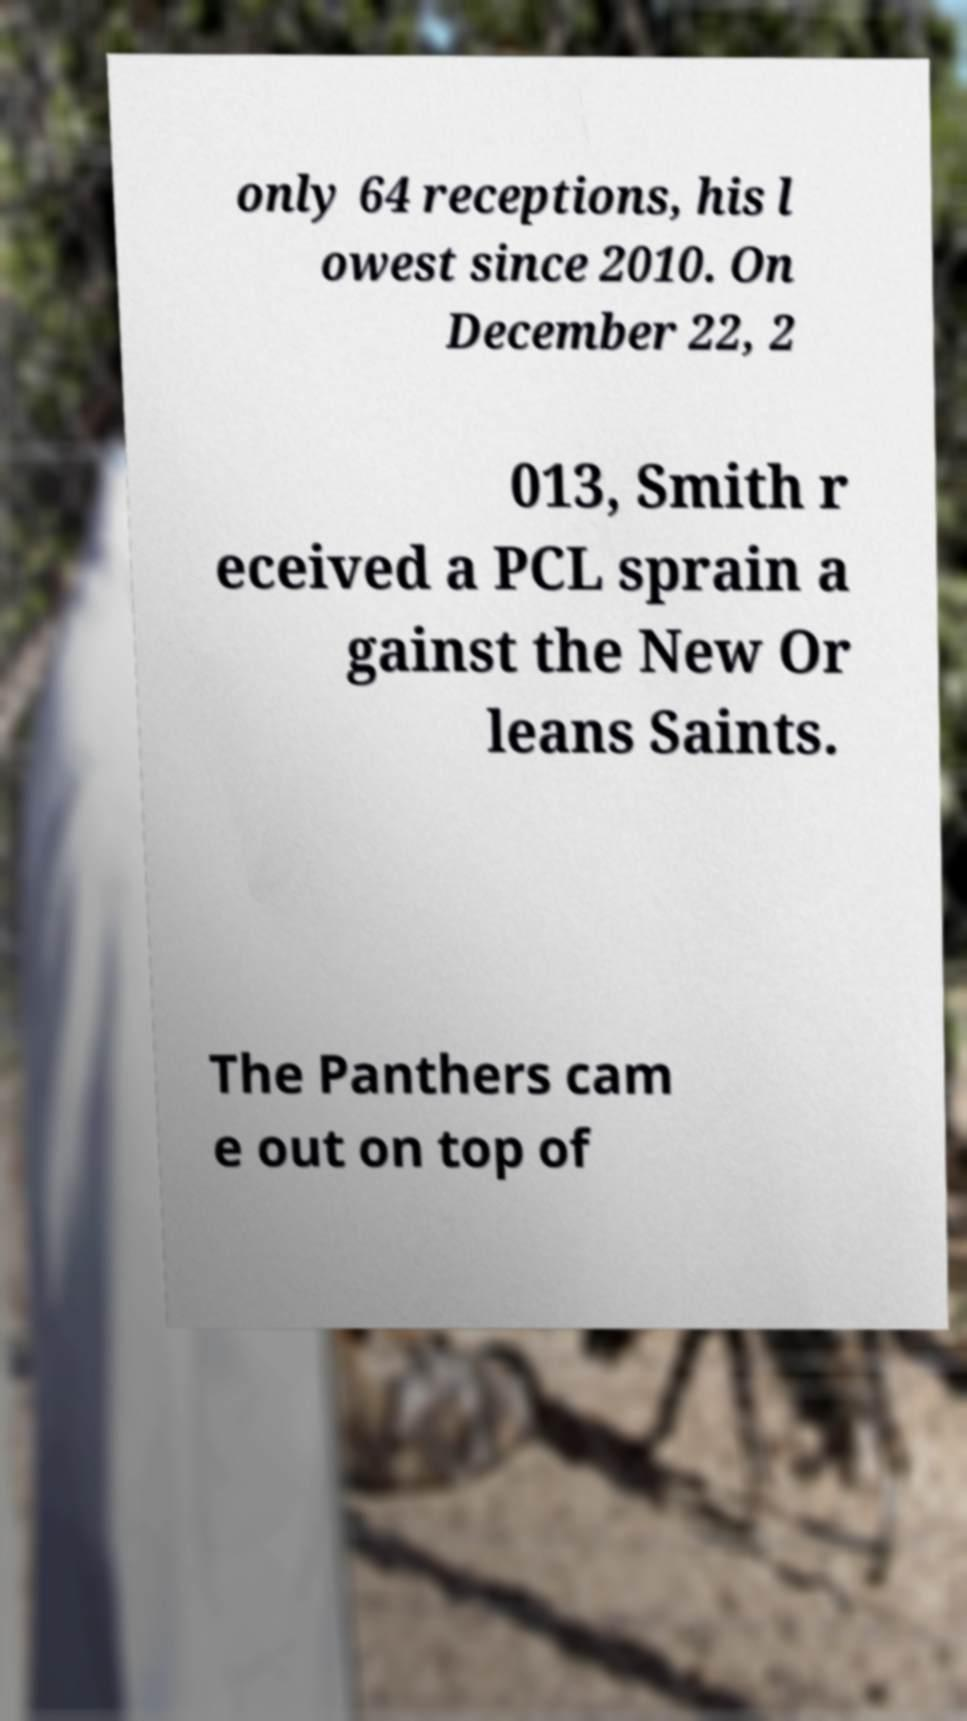Can you read and provide the text displayed in the image?This photo seems to have some interesting text. Can you extract and type it out for me? only 64 receptions, his l owest since 2010. On December 22, 2 013, Smith r eceived a PCL sprain a gainst the New Or leans Saints. The Panthers cam e out on top of 